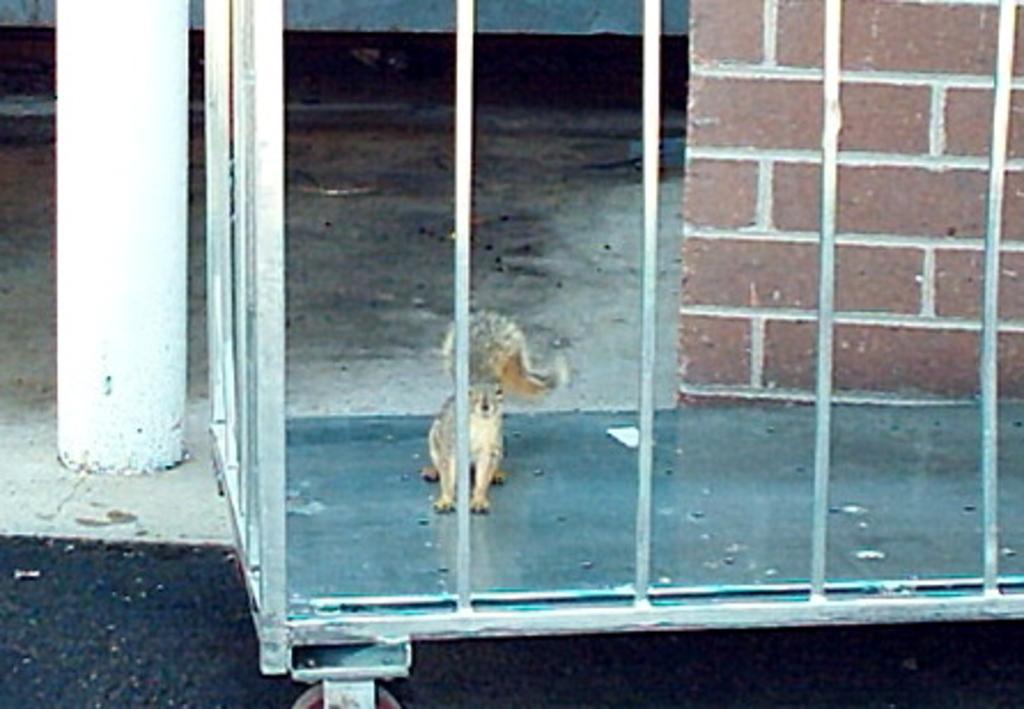Describe this image in one or two sentences. In this image I can see the squirrel on the iron surface and I can also see the grill. In the background I can see the wall and the rod. 